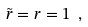Convert formula to latex. <formula><loc_0><loc_0><loc_500><loc_500>\tilde { r } = r = 1 \ ,</formula> 